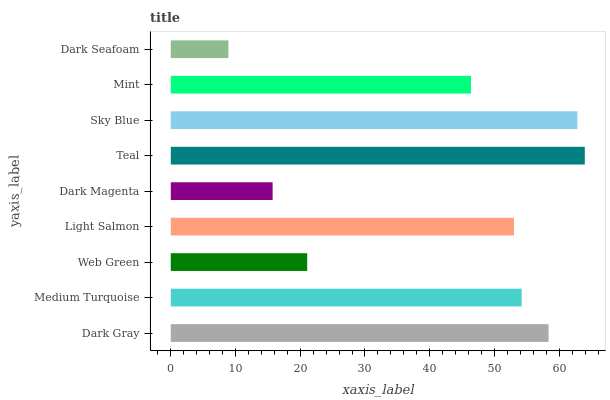Is Dark Seafoam the minimum?
Answer yes or no. Yes. Is Teal the maximum?
Answer yes or no. Yes. Is Medium Turquoise the minimum?
Answer yes or no. No. Is Medium Turquoise the maximum?
Answer yes or no. No. Is Dark Gray greater than Medium Turquoise?
Answer yes or no. Yes. Is Medium Turquoise less than Dark Gray?
Answer yes or no. Yes. Is Medium Turquoise greater than Dark Gray?
Answer yes or no. No. Is Dark Gray less than Medium Turquoise?
Answer yes or no. No. Is Light Salmon the high median?
Answer yes or no. Yes. Is Light Salmon the low median?
Answer yes or no. Yes. Is Mint the high median?
Answer yes or no. No. Is Dark Magenta the low median?
Answer yes or no. No. 